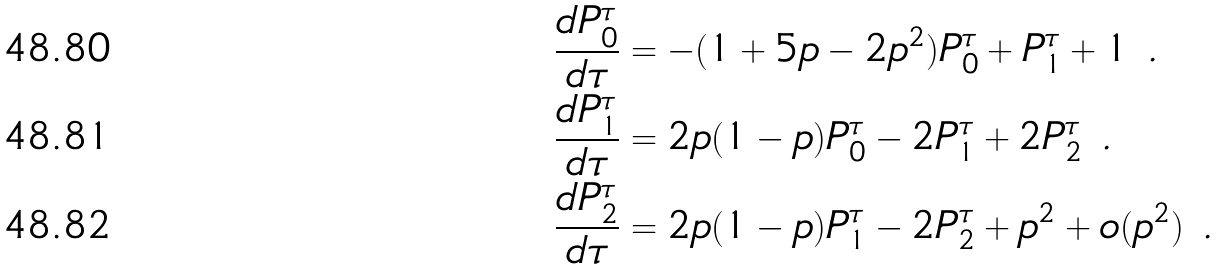Convert formula to latex. <formula><loc_0><loc_0><loc_500><loc_500>\frac { d P _ { 0 } ^ { \tau } } { d \tau } & = - ( 1 + 5 p - 2 p ^ { 2 } ) P ^ { \tau } _ { 0 } + P _ { 1 } ^ { \tau } + 1 \ . \\ \frac { d P _ { 1 } ^ { \tau } } { d \tau } & = 2 p ( 1 - p ) P ^ { \tau } _ { 0 } - 2 P ^ { \tau } _ { 1 } + 2 P ^ { \tau } _ { 2 } \ . \\ \frac { d P _ { 2 } ^ { \tau } } { d \tau } & = 2 p ( 1 - p ) P ^ { \tau } _ { 1 } - 2 P ^ { \tau } _ { 2 } + p ^ { 2 } + o ( p ^ { 2 } ) \ .</formula> 